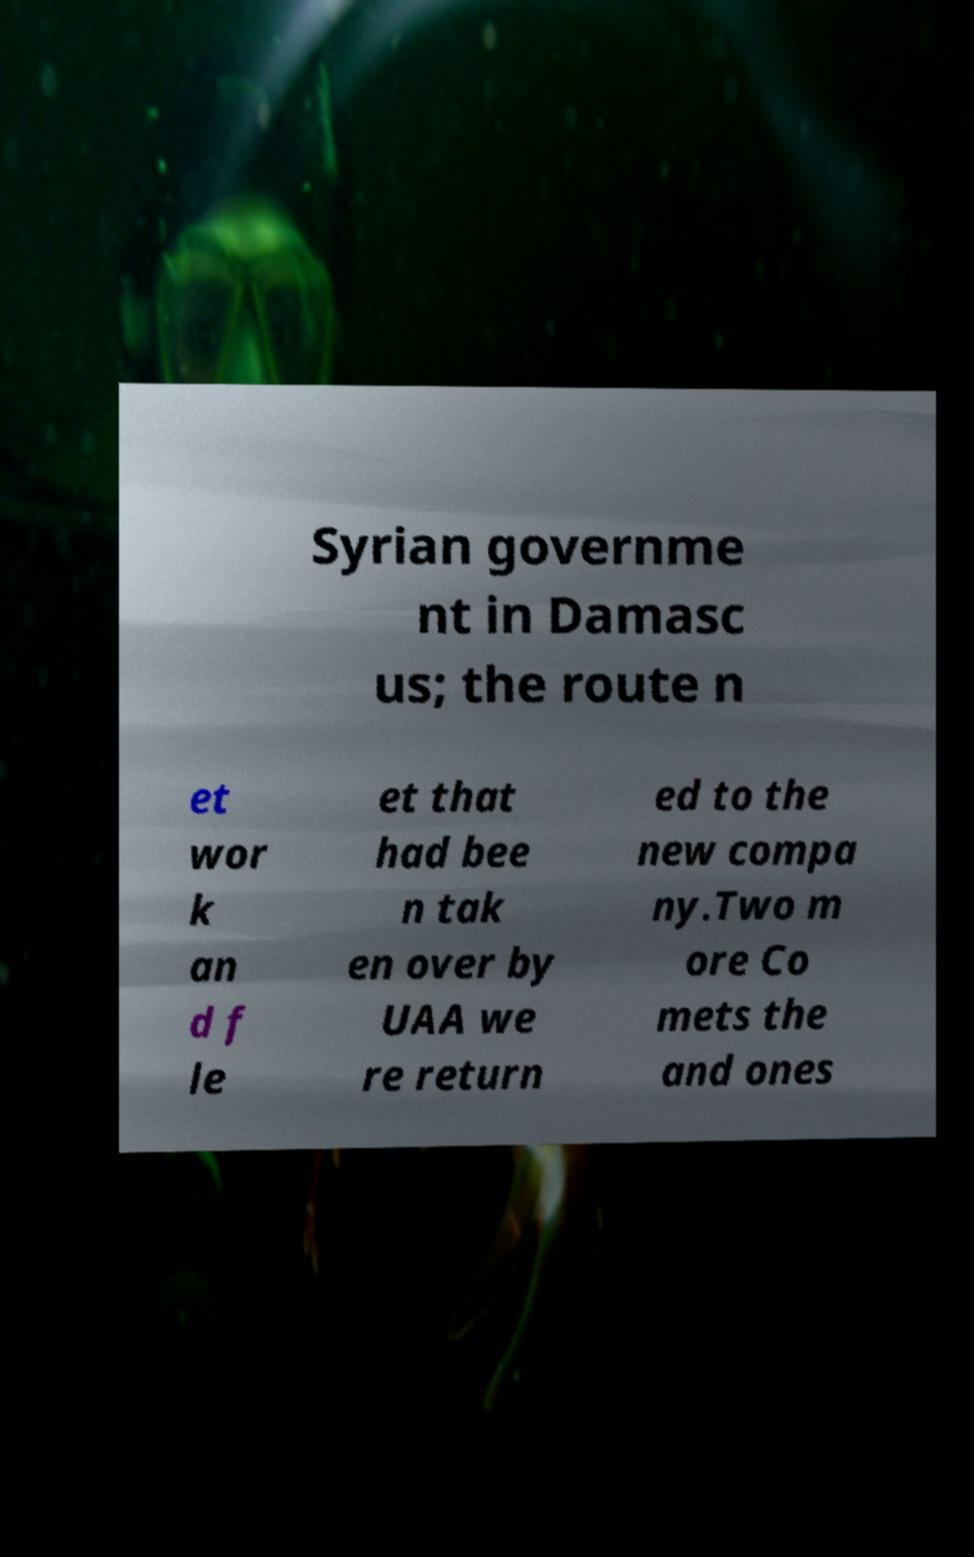There's text embedded in this image that I need extracted. Can you transcribe it verbatim? Syrian governme nt in Damasc us; the route n et wor k an d f le et that had bee n tak en over by UAA we re return ed to the new compa ny.Two m ore Co mets the and ones 